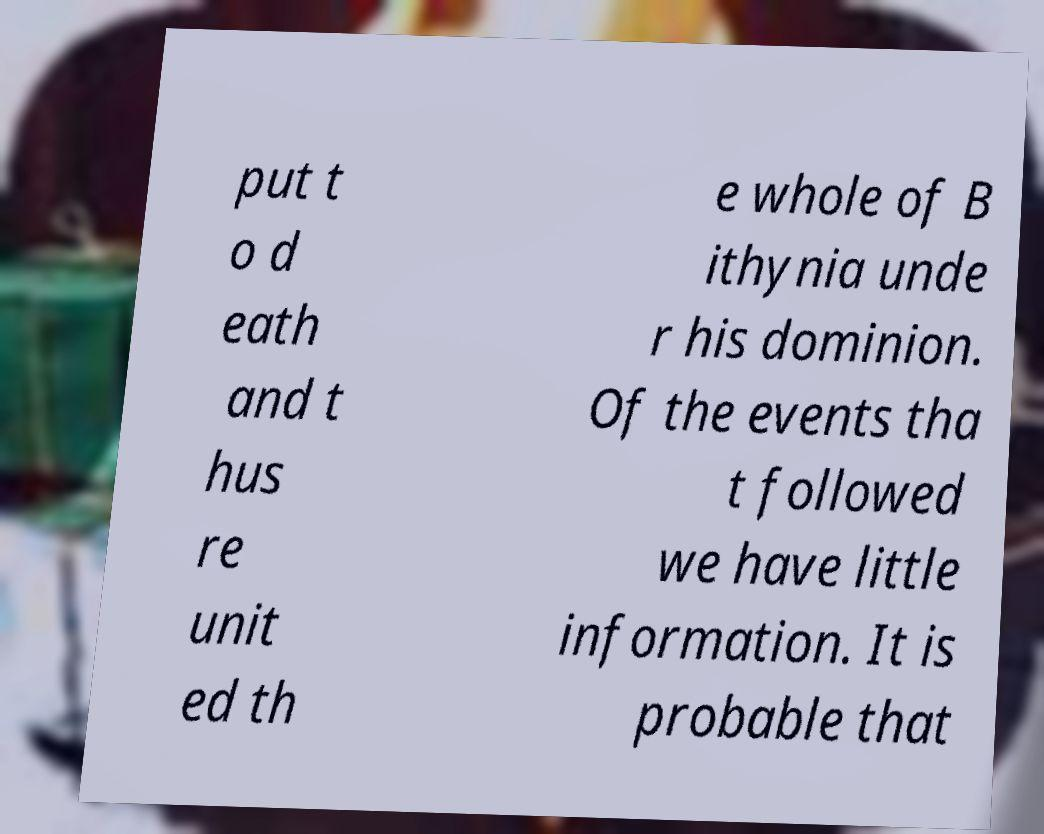For documentation purposes, I need the text within this image transcribed. Could you provide that? put t o d eath and t hus re unit ed th e whole of B ithynia unde r his dominion. Of the events tha t followed we have little information. It is probable that 